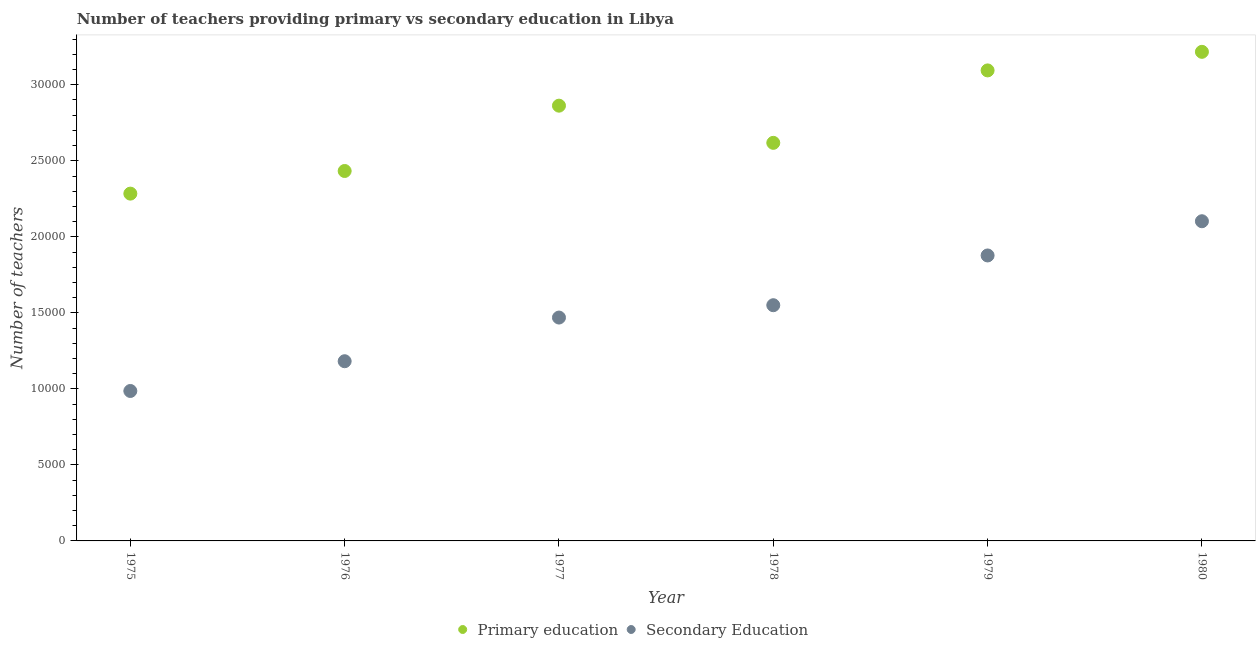How many different coloured dotlines are there?
Keep it short and to the point. 2. Is the number of dotlines equal to the number of legend labels?
Give a very brief answer. Yes. What is the number of secondary teachers in 1980?
Your answer should be very brief. 2.10e+04. Across all years, what is the maximum number of secondary teachers?
Your answer should be very brief. 2.10e+04. Across all years, what is the minimum number of primary teachers?
Offer a terse response. 2.28e+04. In which year was the number of primary teachers minimum?
Ensure brevity in your answer.  1975. What is the total number of primary teachers in the graph?
Your answer should be compact. 1.65e+05. What is the difference between the number of primary teachers in 1975 and that in 1976?
Offer a very short reply. -1489. What is the difference between the number of primary teachers in 1976 and the number of secondary teachers in 1977?
Ensure brevity in your answer.  9640. What is the average number of secondary teachers per year?
Keep it short and to the point. 1.53e+04. In the year 1979, what is the difference between the number of primary teachers and number of secondary teachers?
Make the answer very short. 1.22e+04. What is the ratio of the number of primary teachers in 1975 to that in 1977?
Your response must be concise. 0.8. Is the difference between the number of secondary teachers in 1977 and 1980 greater than the difference between the number of primary teachers in 1977 and 1980?
Your answer should be very brief. No. What is the difference between the highest and the second highest number of secondary teachers?
Offer a very short reply. 2251. What is the difference between the highest and the lowest number of secondary teachers?
Your response must be concise. 1.12e+04. In how many years, is the number of secondary teachers greater than the average number of secondary teachers taken over all years?
Offer a terse response. 3. Does the number of primary teachers monotonically increase over the years?
Offer a terse response. No. Is the number of secondary teachers strictly greater than the number of primary teachers over the years?
Provide a succinct answer. No. How many years are there in the graph?
Your response must be concise. 6. Does the graph contain grids?
Make the answer very short. No. Where does the legend appear in the graph?
Your answer should be compact. Bottom center. What is the title of the graph?
Your answer should be compact. Number of teachers providing primary vs secondary education in Libya. Does "Agricultural land" appear as one of the legend labels in the graph?
Offer a very short reply. No. What is the label or title of the X-axis?
Your response must be concise. Year. What is the label or title of the Y-axis?
Give a very brief answer. Number of teachers. What is the Number of teachers of Primary education in 1975?
Ensure brevity in your answer.  2.28e+04. What is the Number of teachers in Secondary Education in 1975?
Ensure brevity in your answer.  9862. What is the Number of teachers of Primary education in 1976?
Ensure brevity in your answer.  2.43e+04. What is the Number of teachers of Secondary Education in 1976?
Your response must be concise. 1.18e+04. What is the Number of teachers of Primary education in 1977?
Ensure brevity in your answer.  2.86e+04. What is the Number of teachers in Secondary Education in 1977?
Provide a succinct answer. 1.47e+04. What is the Number of teachers of Primary education in 1978?
Your answer should be very brief. 2.62e+04. What is the Number of teachers of Secondary Education in 1978?
Ensure brevity in your answer.  1.55e+04. What is the Number of teachers in Primary education in 1979?
Offer a terse response. 3.09e+04. What is the Number of teachers of Secondary Education in 1979?
Keep it short and to the point. 1.88e+04. What is the Number of teachers of Primary education in 1980?
Make the answer very short. 3.22e+04. What is the Number of teachers in Secondary Education in 1980?
Provide a short and direct response. 2.10e+04. Across all years, what is the maximum Number of teachers of Primary education?
Provide a short and direct response. 3.22e+04. Across all years, what is the maximum Number of teachers in Secondary Education?
Provide a succinct answer. 2.10e+04. Across all years, what is the minimum Number of teachers of Primary education?
Provide a succinct answer. 2.28e+04. Across all years, what is the minimum Number of teachers of Secondary Education?
Your answer should be very brief. 9862. What is the total Number of teachers of Primary education in the graph?
Ensure brevity in your answer.  1.65e+05. What is the total Number of teachers of Secondary Education in the graph?
Your answer should be compact. 9.17e+04. What is the difference between the Number of teachers in Primary education in 1975 and that in 1976?
Offer a very short reply. -1489. What is the difference between the Number of teachers of Secondary Education in 1975 and that in 1976?
Make the answer very short. -1957. What is the difference between the Number of teachers in Primary education in 1975 and that in 1977?
Your answer should be very brief. -5785. What is the difference between the Number of teachers of Secondary Education in 1975 and that in 1977?
Ensure brevity in your answer.  -4829. What is the difference between the Number of teachers of Primary education in 1975 and that in 1978?
Offer a very short reply. -3340. What is the difference between the Number of teachers in Secondary Education in 1975 and that in 1978?
Your answer should be very brief. -5641. What is the difference between the Number of teachers in Primary education in 1975 and that in 1979?
Your answer should be very brief. -8104. What is the difference between the Number of teachers in Secondary Education in 1975 and that in 1979?
Provide a short and direct response. -8913. What is the difference between the Number of teachers of Primary education in 1975 and that in 1980?
Ensure brevity in your answer.  -9326. What is the difference between the Number of teachers of Secondary Education in 1975 and that in 1980?
Offer a terse response. -1.12e+04. What is the difference between the Number of teachers of Primary education in 1976 and that in 1977?
Ensure brevity in your answer.  -4296. What is the difference between the Number of teachers in Secondary Education in 1976 and that in 1977?
Ensure brevity in your answer.  -2872. What is the difference between the Number of teachers of Primary education in 1976 and that in 1978?
Your answer should be compact. -1851. What is the difference between the Number of teachers of Secondary Education in 1976 and that in 1978?
Your response must be concise. -3684. What is the difference between the Number of teachers in Primary education in 1976 and that in 1979?
Provide a short and direct response. -6615. What is the difference between the Number of teachers in Secondary Education in 1976 and that in 1979?
Make the answer very short. -6956. What is the difference between the Number of teachers of Primary education in 1976 and that in 1980?
Give a very brief answer. -7837. What is the difference between the Number of teachers in Secondary Education in 1976 and that in 1980?
Your answer should be very brief. -9207. What is the difference between the Number of teachers of Primary education in 1977 and that in 1978?
Ensure brevity in your answer.  2445. What is the difference between the Number of teachers in Secondary Education in 1977 and that in 1978?
Ensure brevity in your answer.  -812. What is the difference between the Number of teachers of Primary education in 1977 and that in 1979?
Give a very brief answer. -2319. What is the difference between the Number of teachers of Secondary Education in 1977 and that in 1979?
Provide a short and direct response. -4084. What is the difference between the Number of teachers in Primary education in 1977 and that in 1980?
Provide a short and direct response. -3541. What is the difference between the Number of teachers in Secondary Education in 1977 and that in 1980?
Make the answer very short. -6335. What is the difference between the Number of teachers in Primary education in 1978 and that in 1979?
Offer a terse response. -4764. What is the difference between the Number of teachers in Secondary Education in 1978 and that in 1979?
Provide a short and direct response. -3272. What is the difference between the Number of teachers in Primary education in 1978 and that in 1980?
Make the answer very short. -5986. What is the difference between the Number of teachers in Secondary Education in 1978 and that in 1980?
Keep it short and to the point. -5523. What is the difference between the Number of teachers in Primary education in 1979 and that in 1980?
Provide a short and direct response. -1222. What is the difference between the Number of teachers of Secondary Education in 1979 and that in 1980?
Provide a short and direct response. -2251. What is the difference between the Number of teachers of Primary education in 1975 and the Number of teachers of Secondary Education in 1976?
Offer a terse response. 1.10e+04. What is the difference between the Number of teachers in Primary education in 1975 and the Number of teachers in Secondary Education in 1977?
Provide a short and direct response. 8151. What is the difference between the Number of teachers of Primary education in 1975 and the Number of teachers of Secondary Education in 1978?
Offer a very short reply. 7339. What is the difference between the Number of teachers in Primary education in 1975 and the Number of teachers in Secondary Education in 1979?
Offer a very short reply. 4067. What is the difference between the Number of teachers in Primary education in 1975 and the Number of teachers in Secondary Education in 1980?
Give a very brief answer. 1816. What is the difference between the Number of teachers in Primary education in 1976 and the Number of teachers in Secondary Education in 1977?
Provide a succinct answer. 9640. What is the difference between the Number of teachers in Primary education in 1976 and the Number of teachers in Secondary Education in 1978?
Your answer should be very brief. 8828. What is the difference between the Number of teachers of Primary education in 1976 and the Number of teachers of Secondary Education in 1979?
Provide a short and direct response. 5556. What is the difference between the Number of teachers in Primary education in 1976 and the Number of teachers in Secondary Education in 1980?
Ensure brevity in your answer.  3305. What is the difference between the Number of teachers in Primary education in 1977 and the Number of teachers in Secondary Education in 1978?
Offer a terse response. 1.31e+04. What is the difference between the Number of teachers in Primary education in 1977 and the Number of teachers in Secondary Education in 1979?
Offer a terse response. 9852. What is the difference between the Number of teachers of Primary education in 1977 and the Number of teachers of Secondary Education in 1980?
Your answer should be very brief. 7601. What is the difference between the Number of teachers in Primary education in 1978 and the Number of teachers in Secondary Education in 1979?
Your answer should be very brief. 7407. What is the difference between the Number of teachers of Primary education in 1978 and the Number of teachers of Secondary Education in 1980?
Make the answer very short. 5156. What is the difference between the Number of teachers of Primary education in 1979 and the Number of teachers of Secondary Education in 1980?
Offer a very short reply. 9920. What is the average Number of teachers of Primary education per year?
Provide a short and direct response. 2.75e+04. What is the average Number of teachers in Secondary Education per year?
Offer a terse response. 1.53e+04. In the year 1975, what is the difference between the Number of teachers in Primary education and Number of teachers in Secondary Education?
Your response must be concise. 1.30e+04. In the year 1976, what is the difference between the Number of teachers of Primary education and Number of teachers of Secondary Education?
Make the answer very short. 1.25e+04. In the year 1977, what is the difference between the Number of teachers of Primary education and Number of teachers of Secondary Education?
Provide a succinct answer. 1.39e+04. In the year 1978, what is the difference between the Number of teachers of Primary education and Number of teachers of Secondary Education?
Your answer should be very brief. 1.07e+04. In the year 1979, what is the difference between the Number of teachers in Primary education and Number of teachers in Secondary Education?
Offer a terse response. 1.22e+04. In the year 1980, what is the difference between the Number of teachers of Primary education and Number of teachers of Secondary Education?
Provide a succinct answer. 1.11e+04. What is the ratio of the Number of teachers of Primary education in 1975 to that in 1976?
Give a very brief answer. 0.94. What is the ratio of the Number of teachers of Secondary Education in 1975 to that in 1976?
Your answer should be very brief. 0.83. What is the ratio of the Number of teachers of Primary education in 1975 to that in 1977?
Make the answer very short. 0.8. What is the ratio of the Number of teachers in Secondary Education in 1975 to that in 1977?
Offer a very short reply. 0.67. What is the ratio of the Number of teachers of Primary education in 1975 to that in 1978?
Your response must be concise. 0.87. What is the ratio of the Number of teachers of Secondary Education in 1975 to that in 1978?
Offer a very short reply. 0.64. What is the ratio of the Number of teachers in Primary education in 1975 to that in 1979?
Your response must be concise. 0.74. What is the ratio of the Number of teachers in Secondary Education in 1975 to that in 1979?
Ensure brevity in your answer.  0.53. What is the ratio of the Number of teachers in Primary education in 1975 to that in 1980?
Offer a very short reply. 0.71. What is the ratio of the Number of teachers of Secondary Education in 1975 to that in 1980?
Your answer should be very brief. 0.47. What is the ratio of the Number of teachers in Primary education in 1976 to that in 1977?
Offer a very short reply. 0.85. What is the ratio of the Number of teachers of Secondary Education in 1976 to that in 1977?
Keep it short and to the point. 0.8. What is the ratio of the Number of teachers of Primary education in 1976 to that in 1978?
Your answer should be very brief. 0.93. What is the ratio of the Number of teachers of Secondary Education in 1976 to that in 1978?
Provide a short and direct response. 0.76. What is the ratio of the Number of teachers in Primary education in 1976 to that in 1979?
Ensure brevity in your answer.  0.79. What is the ratio of the Number of teachers in Secondary Education in 1976 to that in 1979?
Ensure brevity in your answer.  0.63. What is the ratio of the Number of teachers of Primary education in 1976 to that in 1980?
Your response must be concise. 0.76. What is the ratio of the Number of teachers in Secondary Education in 1976 to that in 1980?
Make the answer very short. 0.56. What is the ratio of the Number of teachers in Primary education in 1977 to that in 1978?
Provide a short and direct response. 1.09. What is the ratio of the Number of teachers of Secondary Education in 1977 to that in 1978?
Your response must be concise. 0.95. What is the ratio of the Number of teachers in Primary education in 1977 to that in 1979?
Make the answer very short. 0.93. What is the ratio of the Number of teachers in Secondary Education in 1977 to that in 1979?
Offer a terse response. 0.78. What is the ratio of the Number of teachers of Primary education in 1977 to that in 1980?
Your answer should be very brief. 0.89. What is the ratio of the Number of teachers in Secondary Education in 1977 to that in 1980?
Provide a short and direct response. 0.7. What is the ratio of the Number of teachers in Primary education in 1978 to that in 1979?
Provide a succinct answer. 0.85. What is the ratio of the Number of teachers of Secondary Education in 1978 to that in 1979?
Provide a succinct answer. 0.83. What is the ratio of the Number of teachers in Primary education in 1978 to that in 1980?
Offer a terse response. 0.81. What is the ratio of the Number of teachers of Secondary Education in 1978 to that in 1980?
Offer a very short reply. 0.74. What is the ratio of the Number of teachers in Primary education in 1979 to that in 1980?
Make the answer very short. 0.96. What is the ratio of the Number of teachers of Secondary Education in 1979 to that in 1980?
Provide a succinct answer. 0.89. What is the difference between the highest and the second highest Number of teachers of Primary education?
Your response must be concise. 1222. What is the difference between the highest and the second highest Number of teachers in Secondary Education?
Ensure brevity in your answer.  2251. What is the difference between the highest and the lowest Number of teachers in Primary education?
Your answer should be very brief. 9326. What is the difference between the highest and the lowest Number of teachers of Secondary Education?
Ensure brevity in your answer.  1.12e+04. 